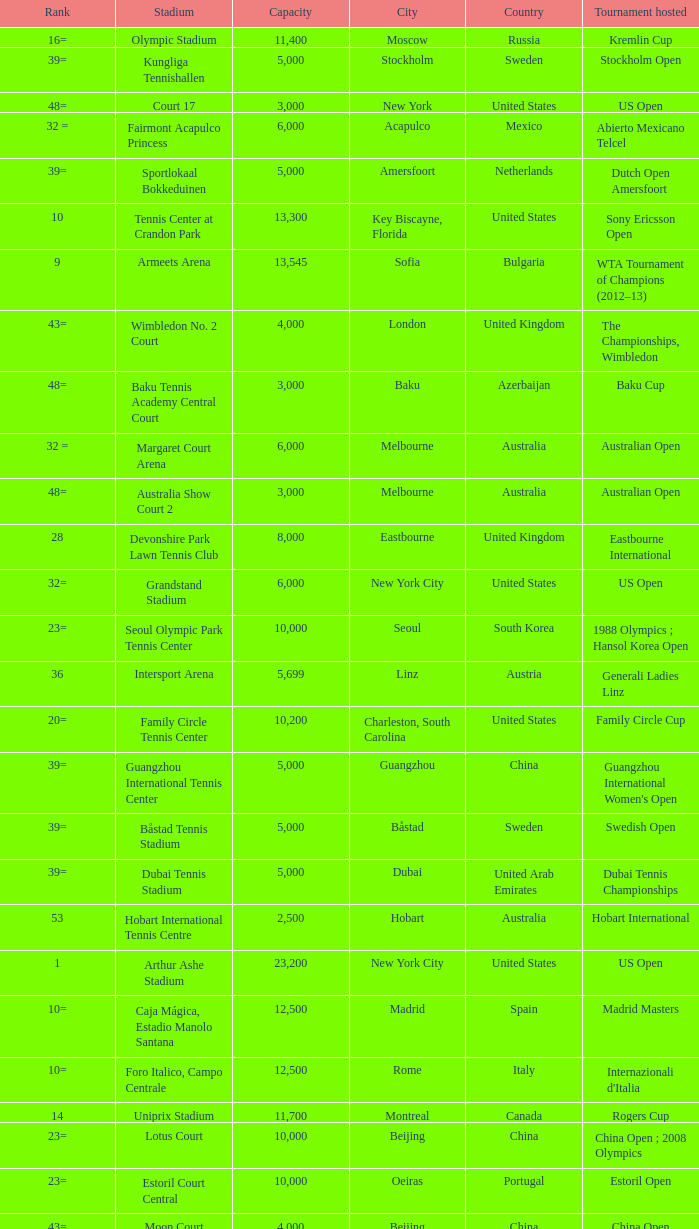What is the average capacity that has rod laver arena as the stadium? 14820.0. 